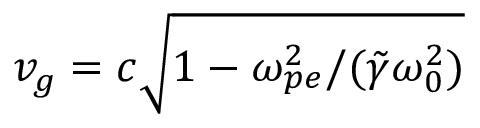Convert formula to latex. <formula><loc_0><loc_0><loc_500><loc_500>v _ { g } = c \sqrt { 1 - \omega _ { p e } ^ { 2 } / ( \tilde { \gamma } \omega _ { 0 } ^ { 2 } ) }</formula> 